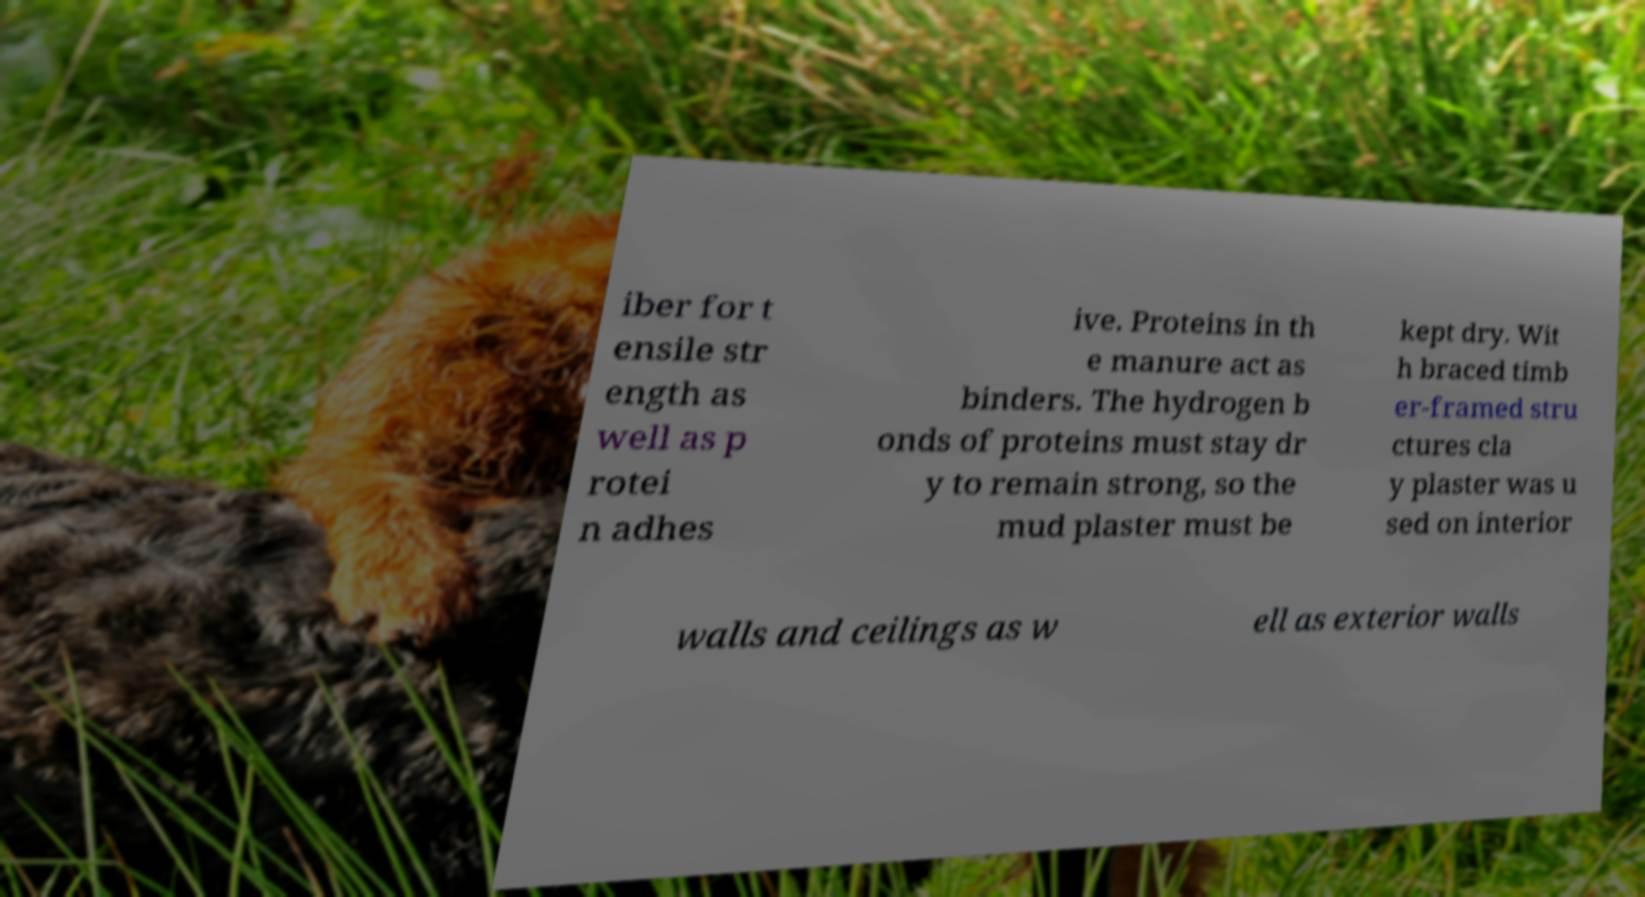Can you accurately transcribe the text from the provided image for me? iber for t ensile str ength as well as p rotei n adhes ive. Proteins in th e manure act as binders. The hydrogen b onds of proteins must stay dr y to remain strong, so the mud plaster must be kept dry. Wit h braced timb er-framed stru ctures cla y plaster was u sed on interior walls and ceilings as w ell as exterior walls 